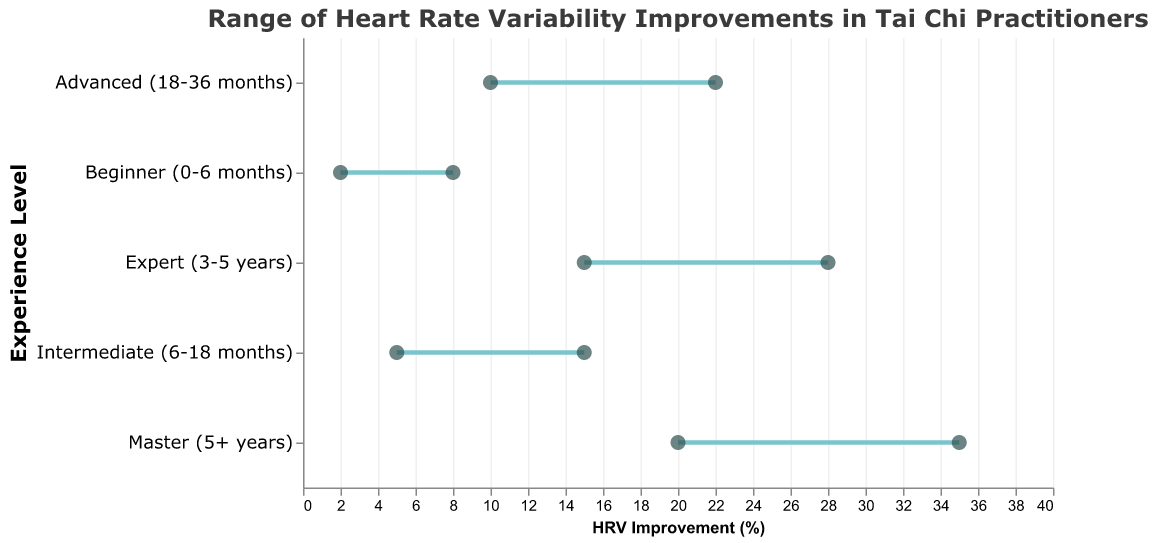What is the title of the chart? The title can be found at the top of the chart, describing the overall content.
Answer: Range of Heart Rate Variability Improvements in Tai Chi Practitioners Which experience level shows the highest maximum HRV improvement? The highest maximum HRV improvement can be found at the end of the topmost line in the chart.
Answer: Master (5+ years) How much is the maximum HRV improvement for Intermediate practitioners? The maximum HRV improvement for Intermediate practitioners is observed by identifying the end point of the Intermediate line.
Answer: 15% What is the range of HRV improvements for Advanced practitioners? To find the range, subtract the minimum HRV improvement from the maximum HRV improvement for Advanced practitioners.
Answer: 12% (22% - 10%) What is the improvement range for the Expert practitioners? The improvement range for Expert practitioners is calculated by subtracting the minimum improvement value from the maximum improvement value.
Answer: 13% (28% - 15%) How does the minimum HRV improvement of Masters compare to the maximum HRV improvement of Beginners? Compare the minimum HRV improvement value for Masters with the maximum HRV improvement value for Beginners.
Answer: 20% (Masters) is higher than 8% (Beginners) Which experience level has the smallest range in HRV improvement? By observing the length of the lines representing each experience level, identify which line is the shortest.
Answer: Beginners (6%) What is the average maximum HRV improvement across all experience levels? First, sum up all maximum HRV improvements, then divide by the number of experience levels, which is 5.
Answer: (8 + 15 + 22 + 28 + 35) / 5 = 21.6% What is the total range of HRV improvement covered by all experience levels combined? Identify the minimum HRV improvement of the Beginners and the maximum HRV improvement of the Masters, then subtract the former from the latter.
Answer: 33% (35% - 2%) What trend can be observed in the HRV improvement ranges as experience level increases? By following the lines from top to bottom, observe how the values change with increasing experience.
Answer: Higher experience levels generally show greater ranges of HRV improvements 